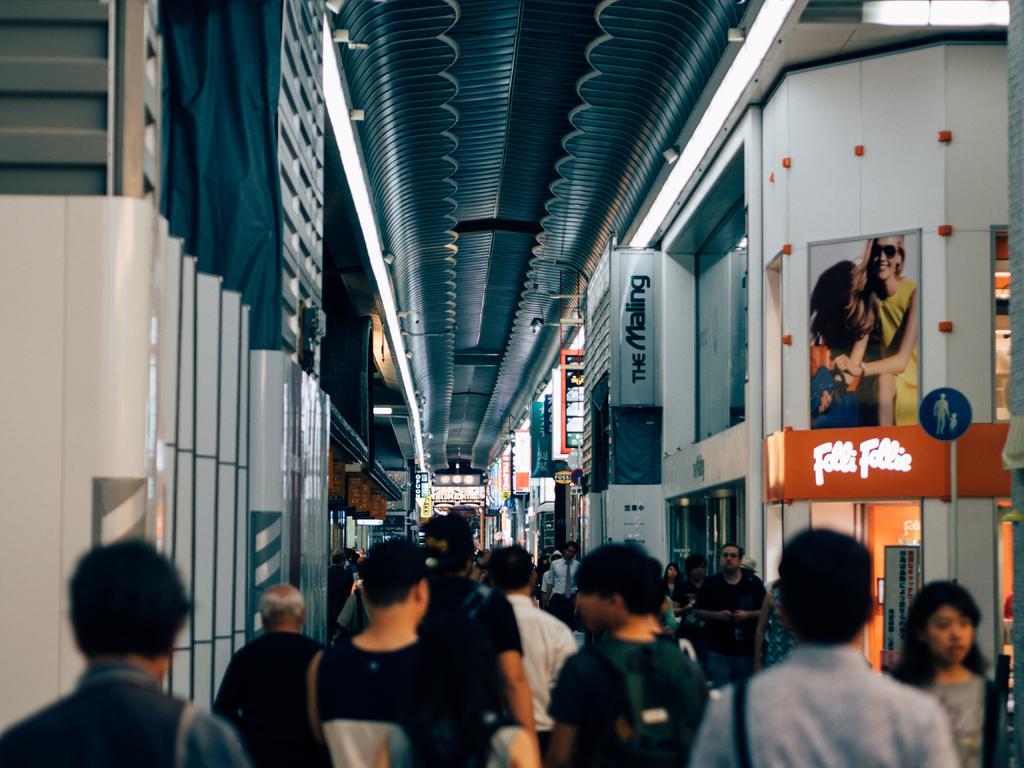How would you summarize this image in a sentence or two? In this image there is a group of persons standing on the bottom of this image and there is a wall in the background. 